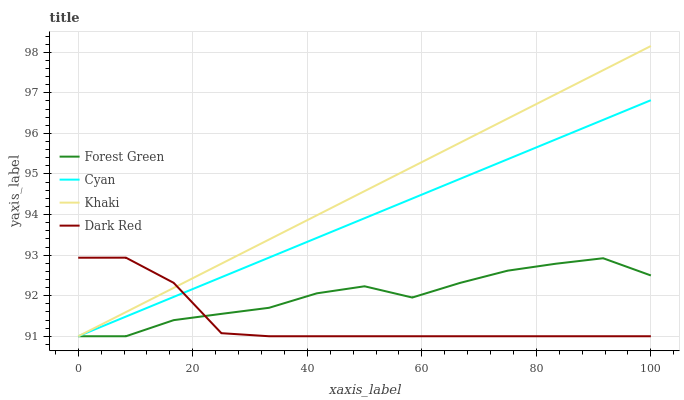Does Dark Red have the minimum area under the curve?
Answer yes or no. Yes. Does Khaki have the maximum area under the curve?
Answer yes or no. Yes. Does Forest Green have the minimum area under the curve?
Answer yes or no. No. Does Forest Green have the maximum area under the curve?
Answer yes or no. No. Is Cyan the smoothest?
Answer yes or no. Yes. Is Forest Green the roughest?
Answer yes or no. Yes. Is Khaki the smoothest?
Answer yes or no. No. Is Khaki the roughest?
Answer yes or no. No. Does Cyan have the lowest value?
Answer yes or no. Yes. Does Khaki have the highest value?
Answer yes or no. Yes. Does Forest Green have the highest value?
Answer yes or no. No. Does Cyan intersect Khaki?
Answer yes or no. Yes. Is Cyan less than Khaki?
Answer yes or no. No. Is Cyan greater than Khaki?
Answer yes or no. No. 